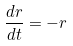<formula> <loc_0><loc_0><loc_500><loc_500>\frac { d r } { d t } = - r</formula> 